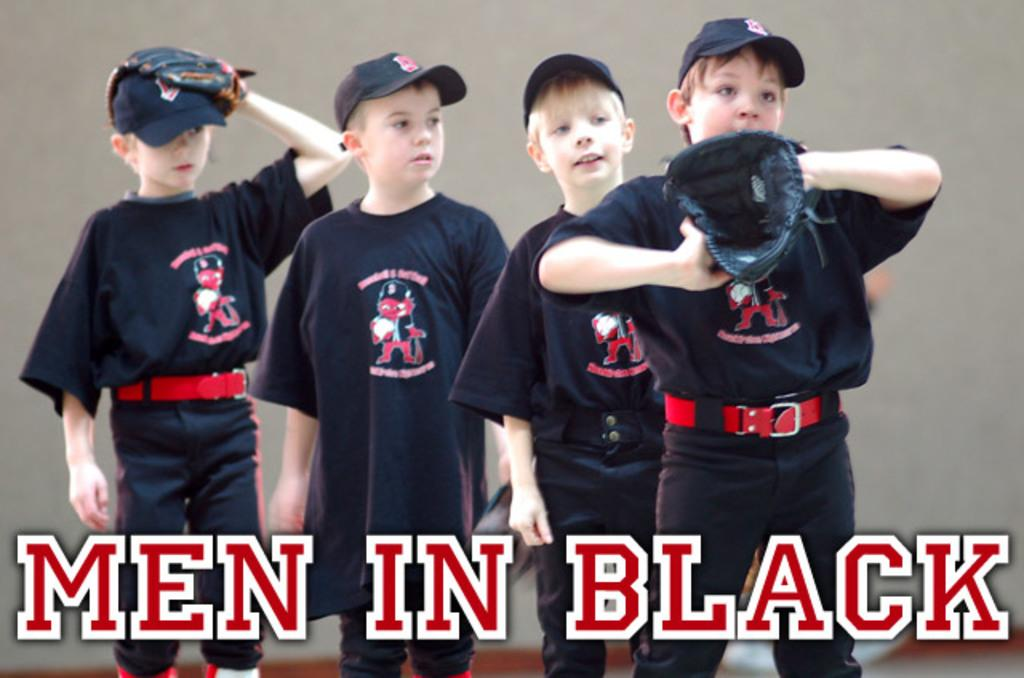<image>
Relay a brief, clear account of the picture shown. young boys in baseball uniforms with the words Men In Black over them 